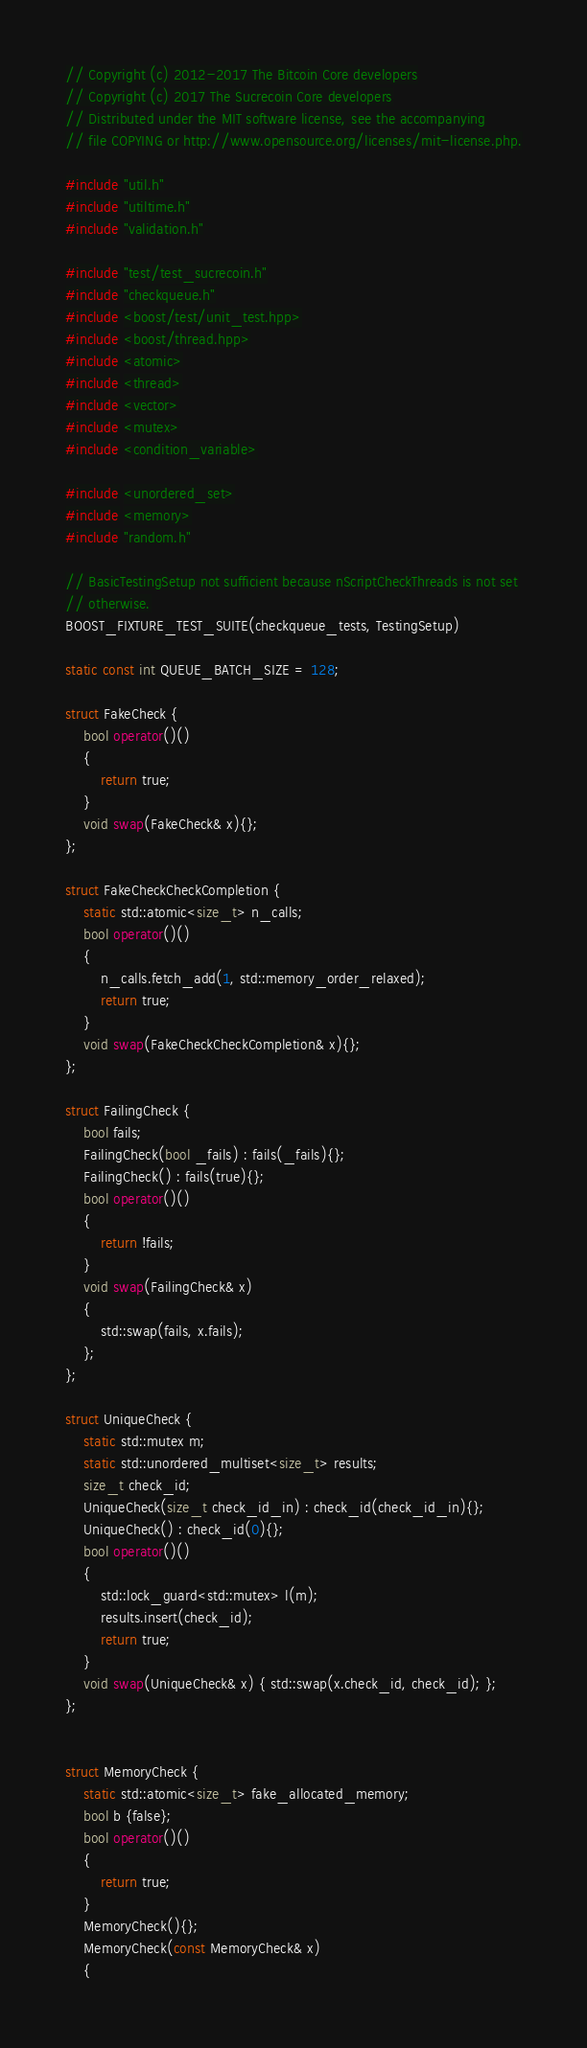<code> <loc_0><loc_0><loc_500><loc_500><_C++_>// Copyright (c) 2012-2017 The Bitcoin Core developers
// Copyright (c) 2017 The Sucrecoin Core developers
// Distributed under the MIT software license, see the accompanying
// file COPYING or http://www.opensource.org/licenses/mit-license.php.

#include "util.h"
#include "utiltime.h"
#include "validation.h"

#include "test/test_sucrecoin.h"
#include "checkqueue.h"
#include <boost/test/unit_test.hpp>
#include <boost/thread.hpp>
#include <atomic>
#include <thread>
#include <vector>
#include <mutex>
#include <condition_variable>

#include <unordered_set>
#include <memory>
#include "random.h"

// BasicTestingSetup not sufficient because nScriptCheckThreads is not set
// otherwise.
BOOST_FIXTURE_TEST_SUITE(checkqueue_tests, TestingSetup)

static const int QUEUE_BATCH_SIZE = 128;

struct FakeCheck {
    bool operator()()
    {
        return true;
    }
    void swap(FakeCheck& x){};
};

struct FakeCheckCheckCompletion {
    static std::atomic<size_t> n_calls;
    bool operator()()
    {
        n_calls.fetch_add(1, std::memory_order_relaxed);
        return true;
    }
    void swap(FakeCheckCheckCompletion& x){};
};

struct FailingCheck {
    bool fails;
    FailingCheck(bool _fails) : fails(_fails){};
    FailingCheck() : fails(true){};
    bool operator()()
    {
        return !fails;
    }
    void swap(FailingCheck& x)
    {
        std::swap(fails, x.fails);
    };
};

struct UniqueCheck {
    static std::mutex m;
    static std::unordered_multiset<size_t> results;
    size_t check_id;
    UniqueCheck(size_t check_id_in) : check_id(check_id_in){};
    UniqueCheck() : check_id(0){};
    bool operator()()
    {
        std::lock_guard<std::mutex> l(m);
        results.insert(check_id);
        return true;
    }
    void swap(UniqueCheck& x) { std::swap(x.check_id, check_id); };
};


struct MemoryCheck {
    static std::atomic<size_t> fake_allocated_memory;
    bool b {false};
    bool operator()()
    {
        return true;
    }
    MemoryCheck(){};
    MemoryCheck(const MemoryCheck& x)
    {</code> 